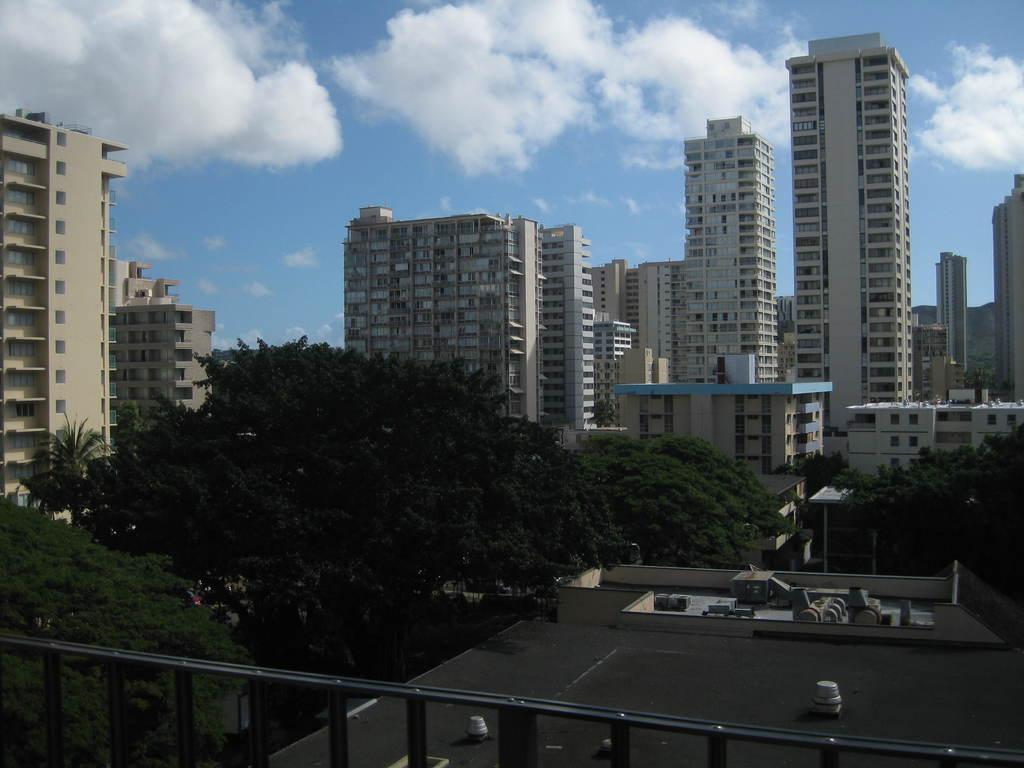What type of structures are visible in the image? There are many buildings in the image. What feature do the buildings have in common? The buildings have windows. What is the purpose of the fence in the image? The purpose of the fence is not explicitly stated, but it could be to mark a boundary or provide security. What type of vegetation is present in the image? There are trees in the image. How would you describe the weather based on the image? The sky is cloudy in the image, which suggests a potentially overcast or cloudy day. How does the iron grip the buildings in the image? There is no iron present in the image, and therefore no such action can be observed. 